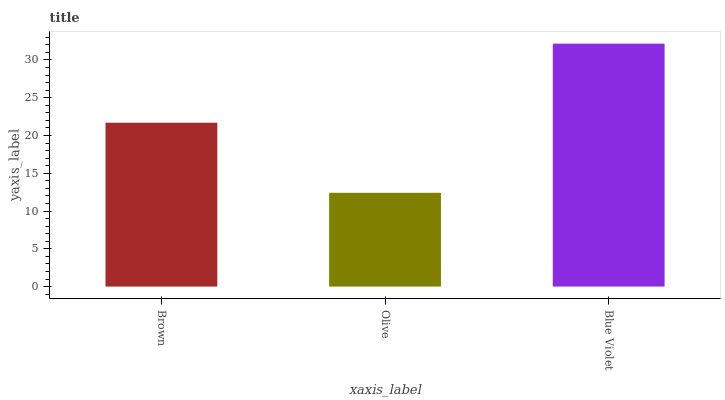Is Olive the minimum?
Answer yes or no. Yes. Is Blue Violet the maximum?
Answer yes or no. Yes. Is Blue Violet the minimum?
Answer yes or no. No. Is Olive the maximum?
Answer yes or no. No. Is Blue Violet greater than Olive?
Answer yes or no. Yes. Is Olive less than Blue Violet?
Answer yes or no. Yes. Is Olive greater than Blue Violet?
Answer yes or no. No. Is Blue Violet less than Olive?
Answer yes or no. No. Is Brown the high median?
Answer yes or no. Yes. Is Brown the low median?
Answer yes or no. Yes. Is Olive the high median?
Answer yes or no. No. Is Blue Violet the low median?
Answer yes or no. No. 